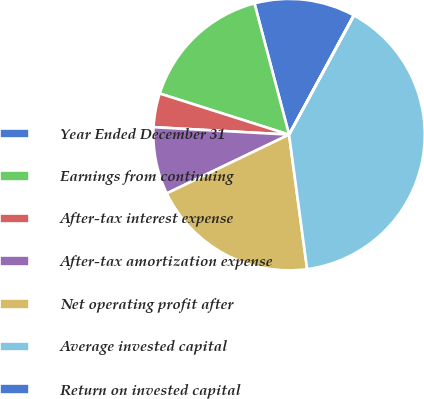Convert chart. <chart><loc_0><loc_0><loc_500><loc_500><pie_chart><fcel>Year Ended December 31<fcel>Earnings from continuing<fcel>After-tax interest expense<fcel>After-tax amortization expense<fcel>Net operating profit after<fcel>Average invested capital<fcel>Return on invested capital<nl><fcel>12.01%<fcel>16.0%<fcel>4.02%<fcel>8.01%<fcel>19.99%<fcel>39.94%<fcel>0.03%<nl></chart> 